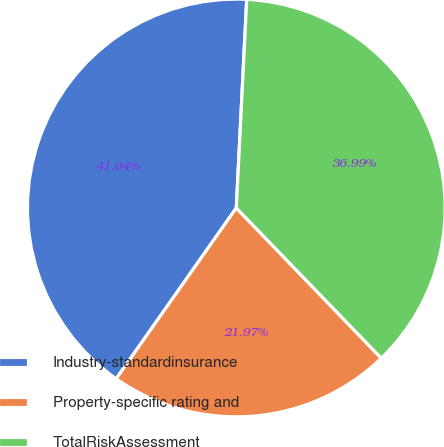Convert chart to OTSL. <chart><loc_0><loc_0><loc_500><loc_500><pie_chart><fcel>Industry-standardinsurance<fcel>Property-specific rating and<fcel>TotalRiskAssessment<nl><fcel>41.04%<fcel>21.97%<fcel>36.99%<nl></chart> 